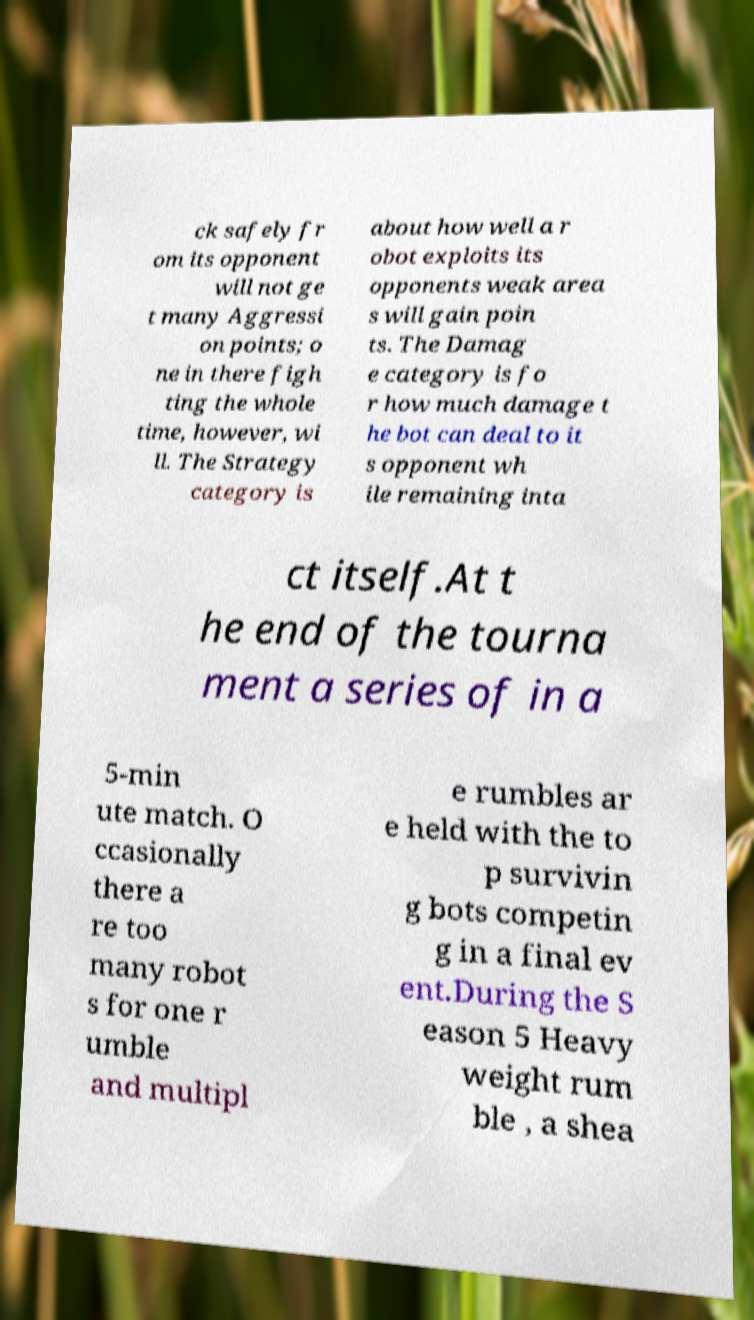Could you extract and type out the text from this image? ck safely fr om its opponent will not ge t many Aggressi on points; o ne in there figh ting the whole time, however, wi ll. The Strategy category is about how well a r obot exploits its opponents weak area s will gain poin ts. The Damag e category is fo r how much damage t he bot can deal to it s opponent wh ile remaining inta ct itself.At t he end of the tourna ment a series of in a 5-min ute match. O ccasionally there a re too many robot s for one r umble and multipl e rumbles ar e held with the to p survivin g bots competin g in a final ev ent.During the S eason 5 Heavy weight rum ble , a shea 